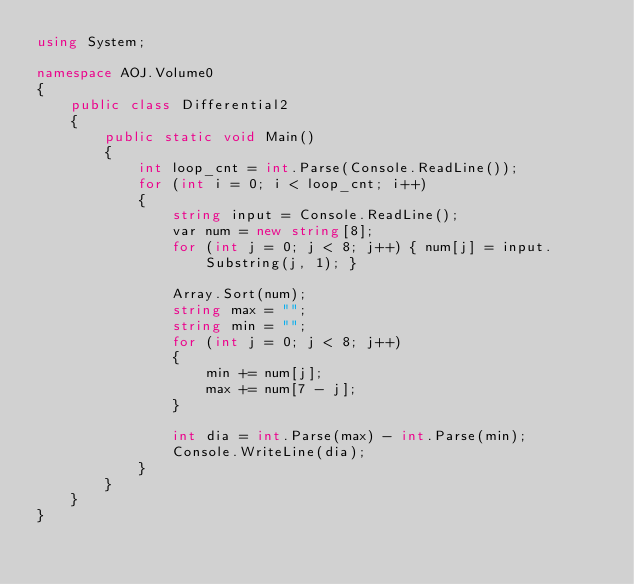Convert code to text. <code><loc_0><loc_0><loc_500><loc_500><_C#_>using System;

namespace AOJ.Volume0
{
    public class Differential2
    {
        public static void Main()
        {
            int loop_cnt = int.Parse(Console.ReadLine());
            for (int i = 0; i < loop_cnt; i++)
            {
                string input = Console.ReadLine();
                var num = new string[8];
                for (int j = 0; j < 8; j++) { num[j] = input.Substring(j, 1); }

                Array.Sort(num);
                string max = "";
                string min = "";
                for (int j = 0; j < 8; j++)
                {
                    min += num[j];
                    max += num[7 - j];
                }

                int dia = int.Parse(max) - int.Parse(min);
                Console.WriteLine(dia);
            }
        }
    }
}</code> 